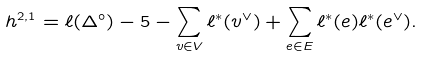Convert formula to latex. <formula><loc_0><loc_0><loc_500><loc_500>h ^ { 2 , 1 } = \ell ( \Delta ^ { \circ } ) - 5 - \sum _ { v \in V } \ell ^ { * } ( v ^ { \vee } ) + \sum _ { e \in E } \ell ^ { * } ( e ) \ell ^ { * } ( e ^ { \vee } ) .</formula> 